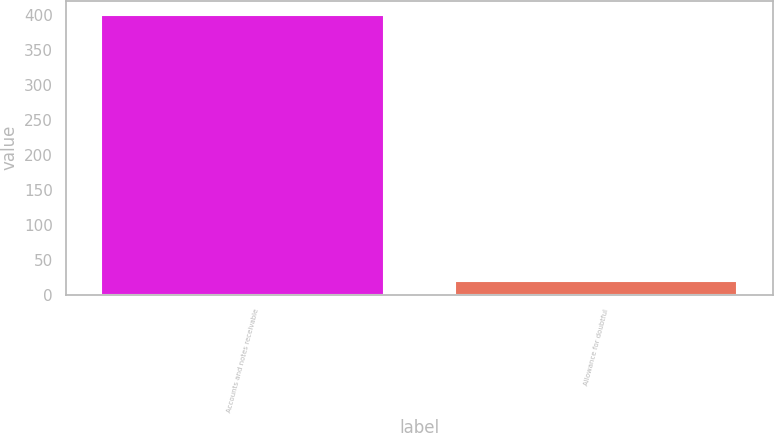<chart> <loc_0><loc_0><loc_500><loc_500><bar_chart><fcel>Accounts and notes receivable<fcel>Allowance for doubtful<nl><fcel>400<fcel>19<nl></chart> 